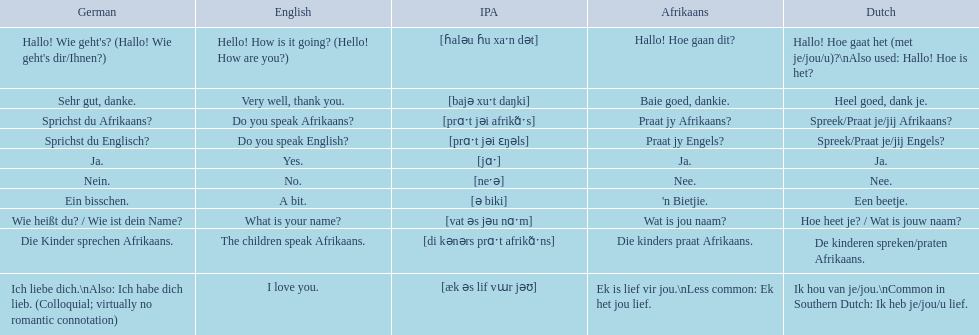Which phrases are said in africaans? Hallo! Hoe gaan dit?, Baie goed, dankie., Praat jy Afrikaans?, Praat jy Engels?, Ja., Nee., 'n Bietjie., Wat is jou naam?, Die kinders praat Afrikaans., Ek is lief vir jou.\nLess common: Ek het jou lief. Which of these mean how do you speak afrikaans? Praat jy Afrikaans?. 